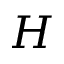Convert formula to latex. <formula><loc_0><loc_0><loc_500><loc_500>H</formula> 